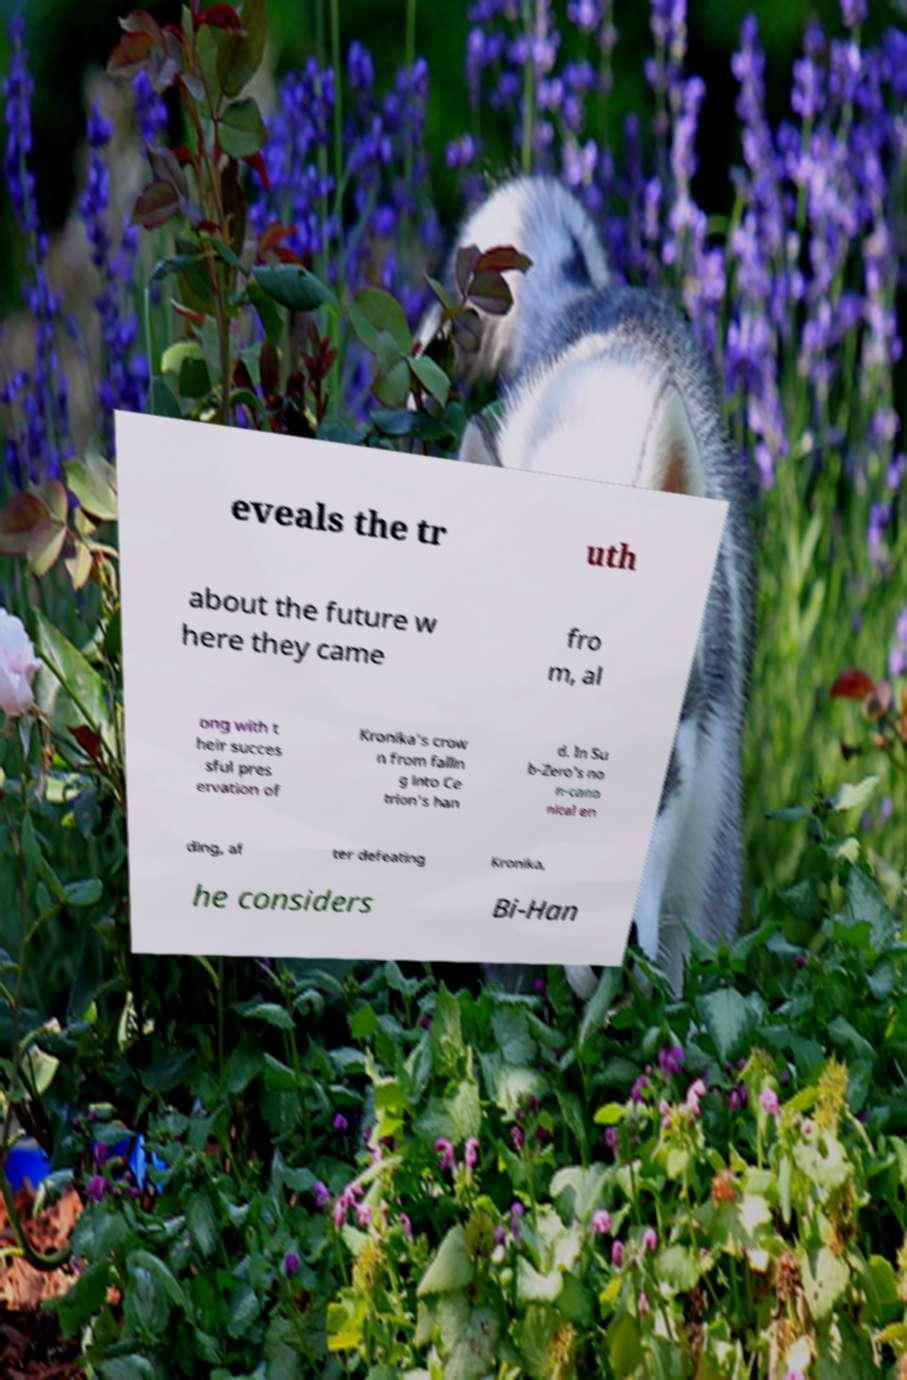Please read and relay the text visible in this image. What does it say? eveals the tr uth about the future w here they came fro m, al ong with t heir succes sful pres ervation of Kronika’s crow n from fallin g into Ce trion’s han d. In Su b-Zero's no n-cano nical en ding, af ter defeating Kronika, he considers Bi-Han 